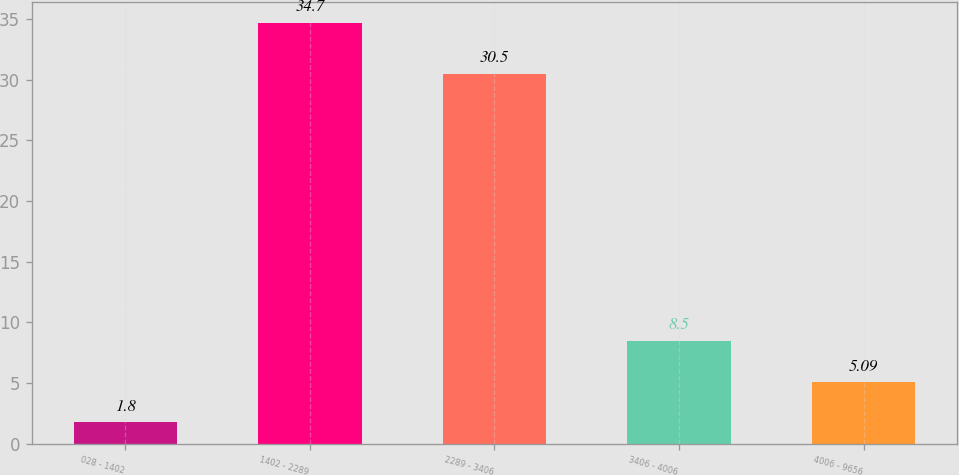<chart> <loc_0><loc_0><loc_500><loc_500><bar_chart><fcel>028 - 1402<fcel>1402 - 2289<fcel>2289 - 3406<fcel>3406 - 4006<fcel>4006 - 9656<nl><fcel>1.8<fcel>34.7<fcel>30.5<fcel>8.5<fcel>5.09<nl></chart> 